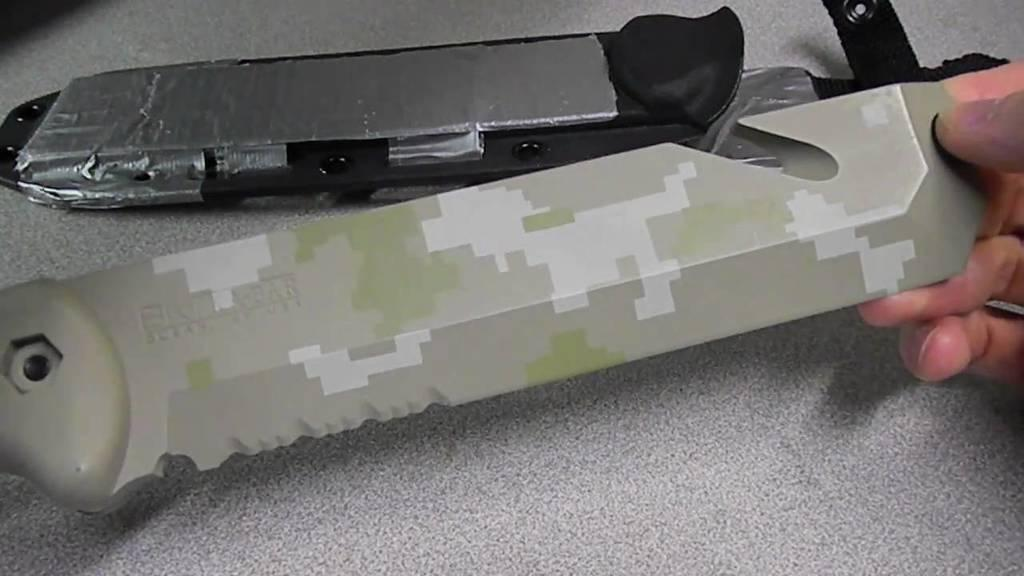What can be seen in the image? There is a person in the image. What is the person doing in the image? The person is holding an object. What is the surface beneath the person in the image? There is a floor visible in the image. What type of wave can be seen crashing in the background of the image? There is no wave present in the image; it only features a person holding an object on a floor. 